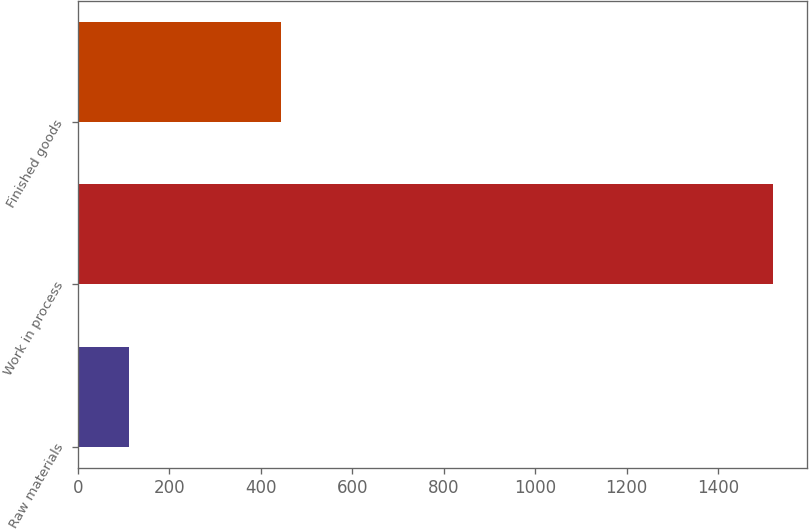Convert chart. <chart><loc_0><loc_0><loc_500><loc_500><bar_chart><fcel>Raw materials<fcel>Work in process<fcel>Finished goods<nl><fcel>112<fcel>1519<fcel>444<nl></chart> 